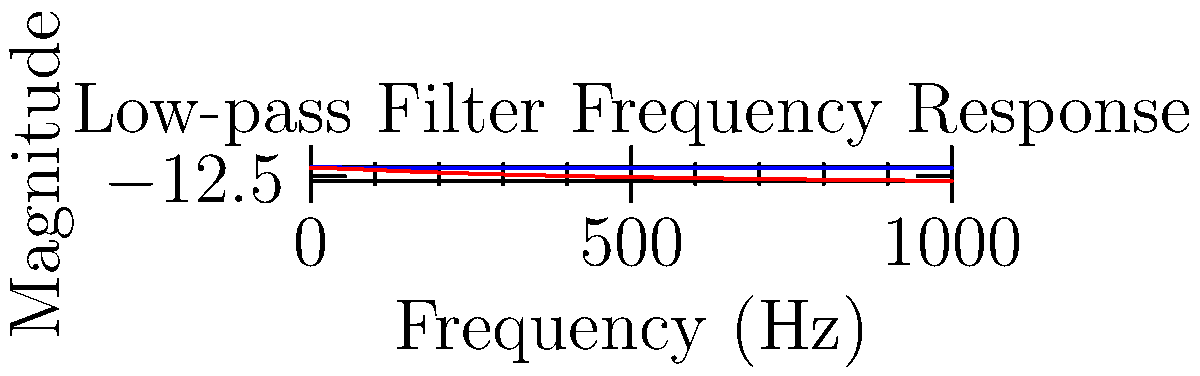In your latest medical drama novel, a neurosurgeon is analyzing EEG signals. She needs to remove high-frequency noise without distorting the important brain wave frequencies. Given the frequency response of a low-pass filter shown above, at what frequency does the filter attenuate the signal by approximately 3 dB? How might this impact the EEG analysis in your story? To solve this problem, we need to understand the concept of the -3 dB point in filter design:

1. The -3 dB point is where the output power is half of the input power.
2. In terms of magnitude, this corresponds to a factor of $1/\sqrt{2} \approx 0.707$.
3. On a dB scale, this is equivalent to $20 \log_{10}(0.707) \approx -3$ dB.

Looking at the red curve (magnitude in dB):
4. We need to find where it crosses the -3 dB line.
5. This occurs at approximately 100 Hz.

This means:
6. Frequencies below 100 Hz will pass through relatively unchanged.
7. Frequencies above 100 Hz will be progressively attenuated.

For the EEG analysis in the story:
8. Most clinically relevant EEG frequencies are below 100 Hz.
9. This filter would effectively remove high-frequency noise (e.g., muscle artifacts) above 100 Hz.
10. It would preserve the important brain wave frequencies (e.g., delta, theta, alpha, beta) which typically range from 0.5 to 30 Hz.

This filter choice allows the neurosurgeon to clean the EEG signal without losing critical information, potentially leading to a more accurate diagnosis or surgical plan in the novel's plot.
Answer: 100 Hz; preserves clinically relevant EEG frequencies while removing high-frequency noise. 